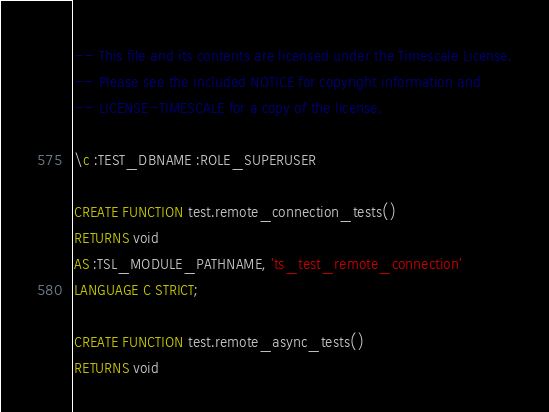Convert code to text. <code><loc_0><loc_0><loc_500><loc_500><_SQL_>-- This file and its contents are licensed under the Timescale License.
-- Please see the included NOTICE for copyright information and
-- LICENSE-TIMESCALE for a copy of the license.

\c :TEST_DBNAME :ROLE_SUPERUSER

CREATE FUNCTION test.remote_connection_tests()
RETURNS void
AS :TSL_MODULE_PATHNAME, 'ts_test_remote_connection'
LANGUAGE C STRICT;

CREATE FUNCTION test.remote_async_tests()
RETURNS void</code> 